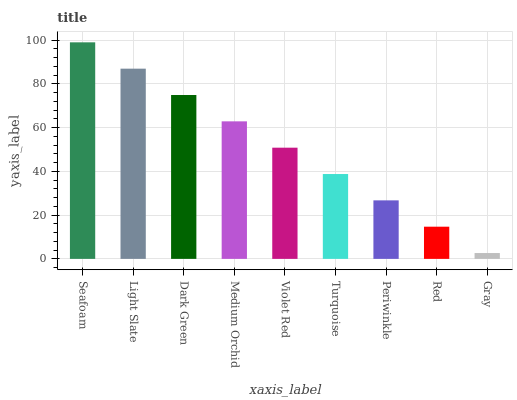Is Gray the minimum?
Answer yes or no. Yes. Is Seafoam the maximum?
Answer yes or no. Yes. Is Light Slate the minimum?
Answer yes or no. No. Is Light Slate the maximum?
Answer yes or no. No. Is Seafoam greater than Light Slate?
Answer yes or no. Yes. Is Light Slate less than Seafoam?
Answer yes or no. Yes. Is Light Slate greater than Seafoam?
Answer yes or no. No. Is Seafoam less than Light Slate?
Answer yes or no. No. Is Violet Red the high median?
Answer yes or no. Yes. Is Violet Red the low median?
Answer yes or no. Yes. Is Medium Orchid the high median?
Answer yes or no. No. Is Medium Orchid the low median?
Answer yes or no. No. 